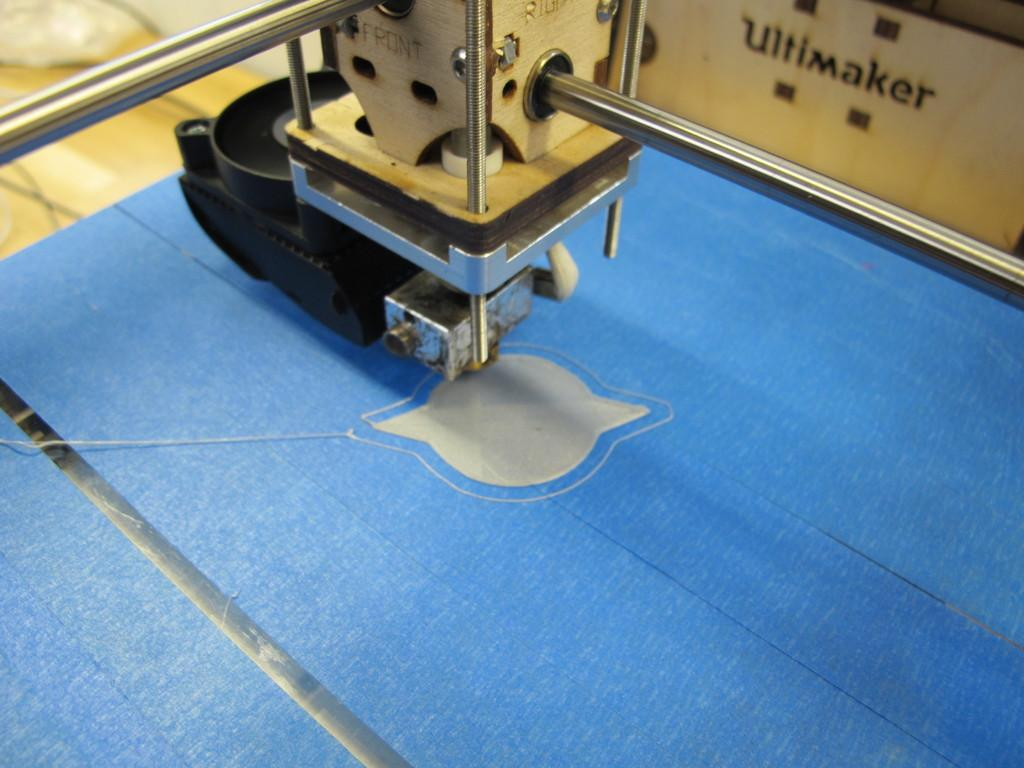What is the main object in the image? There is a machine in the image. What is located at the bottom of the image? There is a sheet at the bottom of the image. What is situated at the back of the image? There is a box at the back of the image. What can be found on the box? There is text on the box. What else is visible in the image? There are wires in the image. Can you tell me how many monkeys are sitting on the machine in the image? There are no monkeys present in the image. How does the passenger interact with the machine in the image? There is no passenger present in the image. 